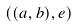<formula> <loc_0><loc_0><loc_500><loc_500>( ( a , b ) , e )</formula> 